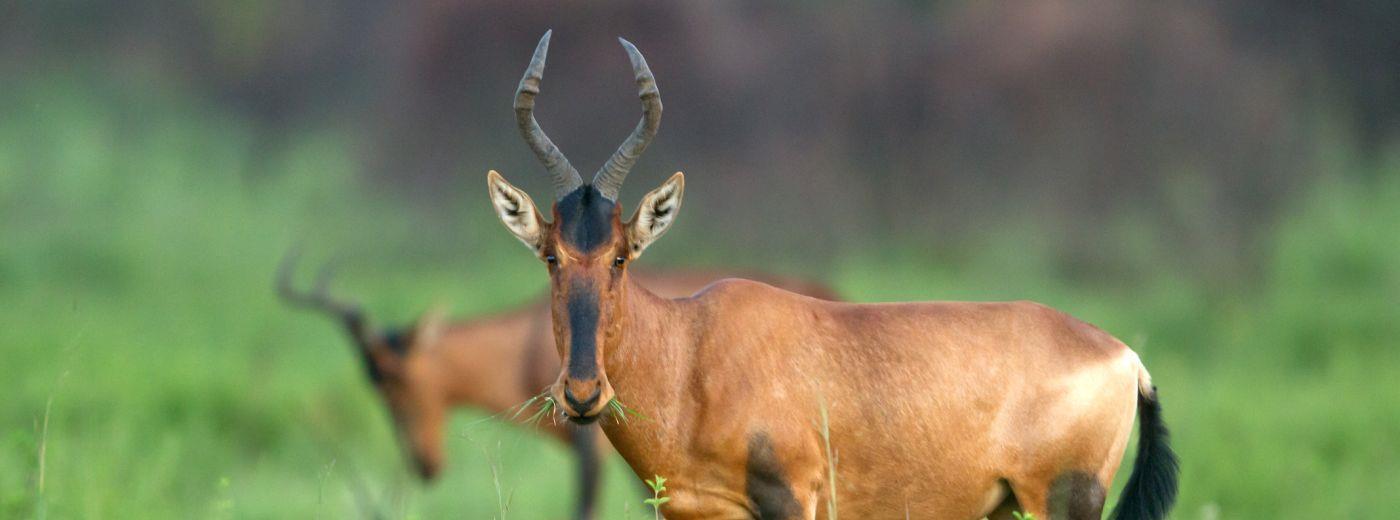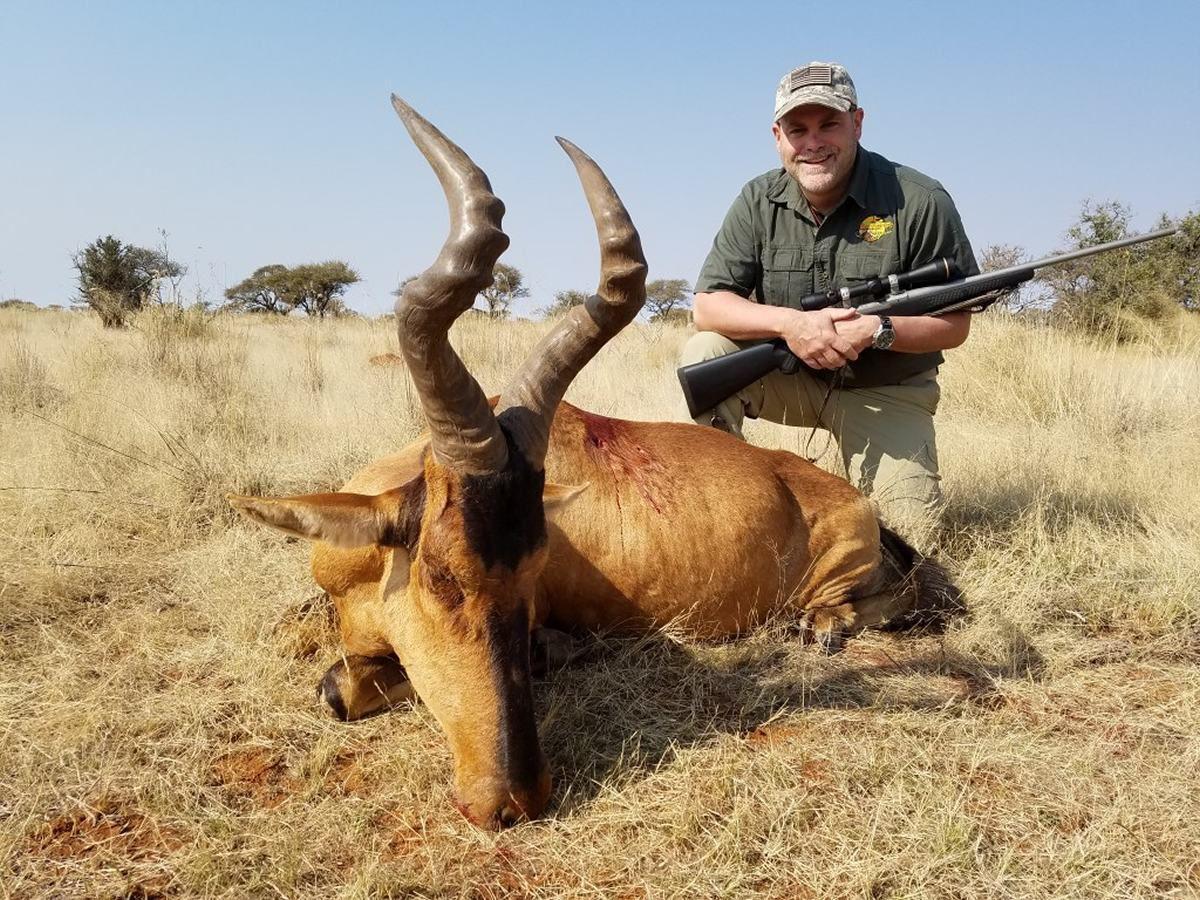The first image is the image on the left, the second image is the image on the right. Considering the images on both sides, is "In one of the images there is a person posing behind an antelope." valid? Answer yes or no. Yes. The first image is the image on the left, the second image is the image on the right. Analyze the images presented: Is the assertion "A hunter with a gun poses behind a downed horned animal in one image." valid? Answer yes or no. Yes. 